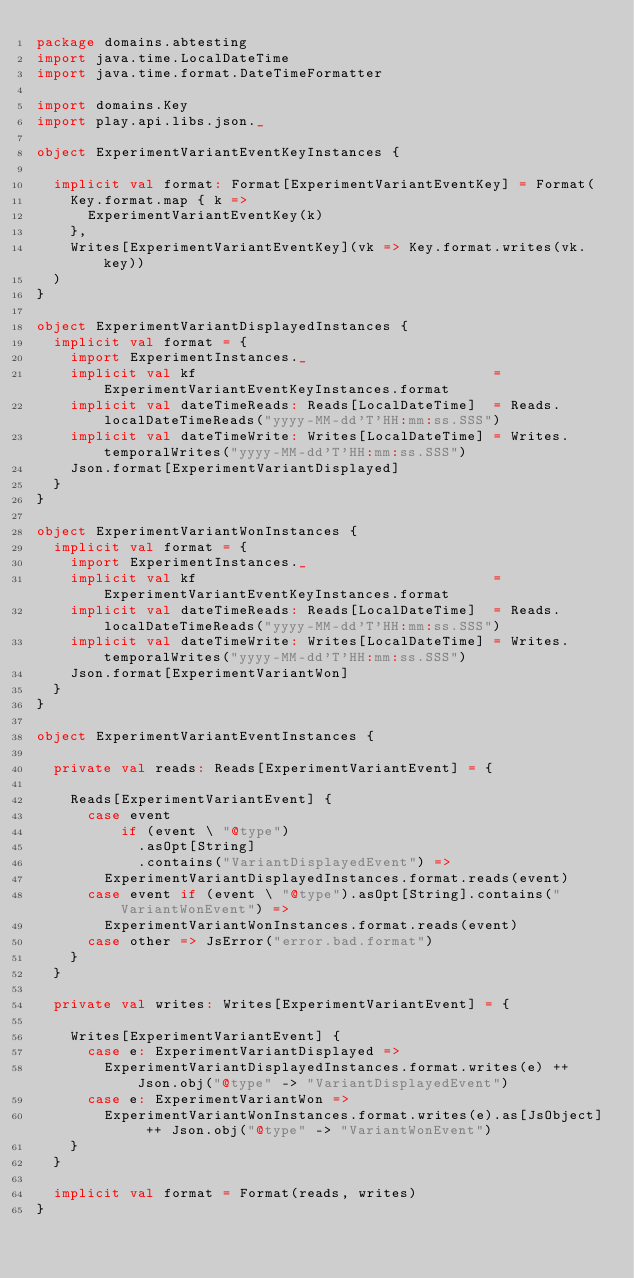Convert code to text. <code><loc_0><loc_0><loc_500><loc_500><_Scala_>package domains.abtesting
import java.time.LocalDateTime
import java.time.format.DateTimeFormatter

import domains.Key
import play.api.libs.json._

object ExperimentVariantEventKeyInstances {

  implicit val format: Format[ExperimentVariantEventKey] = Format(
    Key.format.map { k =>
      ExperimentVariantEventKey(k)
    },
    Writes[ExperimentVariantEventKey](vk => Key.format.writes(vk.key))
  )
}

object ExperimentVariantDisplayedInstances {
  implicit val format = {
    import ExperimentInstances._
    implicit val kf                                   = ExperimentVariantEventKeyInstances.format
    implicit val dateTimeReads: Reads[LocalDateTime]  = Reads.localDateTimeReads("yyyy-MM-dd'T'HH:mm:ss.SSS")
    implicit val dateTimeWrite: Writes[LocalDateTime] = Writes.temporalWrites("yyyy-MM-dd'T'HH:mm:ss.SSS")
    Json.format[ExperimentVariantDisplayed]
  }
}

object ExperimentVariantWonInstances {
  implicit val format = {
    import ExperimentInstances._
    implicit val kf                                   = ExperimentVariantEventKeyInstances.format
    implicit val dateTimeReads: Reads[LocalDateTime]  = Reads.localDateTimeReads("yyyy-MM-dd'T'HH:mm:ss.SSS")
    implicit val dateTimeWrite: Writes[LocalDateTime] = Writes.temporalWrites("yyyy-MM-dd'T'HH:mm:ss.SSS")
    Json.format[ExperimentVariantWon]
  }
}

object ExperimentVariantEventInstances {

  private val reads: Reads[ExperimentVariantEvent] = {

    Reads[ExperimentVariantEvent] {
      case event
          if (event \ "@type")
            .asOpt[String]
            .contains("VariantDisplayedEvent") =>
        ExperimentVariantDisplayedInstances.format.reads(event)
      case event if (event \ "@type").asOpt[String].contains("VariantWonEvent") =>
        ExperimentVariantWonInstances.format.reads(event)
      case other => JsError("error.bad.format")
    }
  }

  private val writes: Writes[ExperimentVariantEvent] = {

    Writes[ExperimentVariantEvent] {
      case e: ExperimentVariantDisplayed =>
        ExperimentVariantDisplayedInstances.format.writes(e) ++ Json.obj("@type" -> "VariantDisplayedEvent")
      case e: ExperimentVariantWon =>
        ExperimentVariantWonInstances.format.writes(e).as[JsObject] ++ Json.obj("@type" -> "VariantWonEvent")
    }
  }

  implicit val format = Format(reads, writes)
}
</code> 